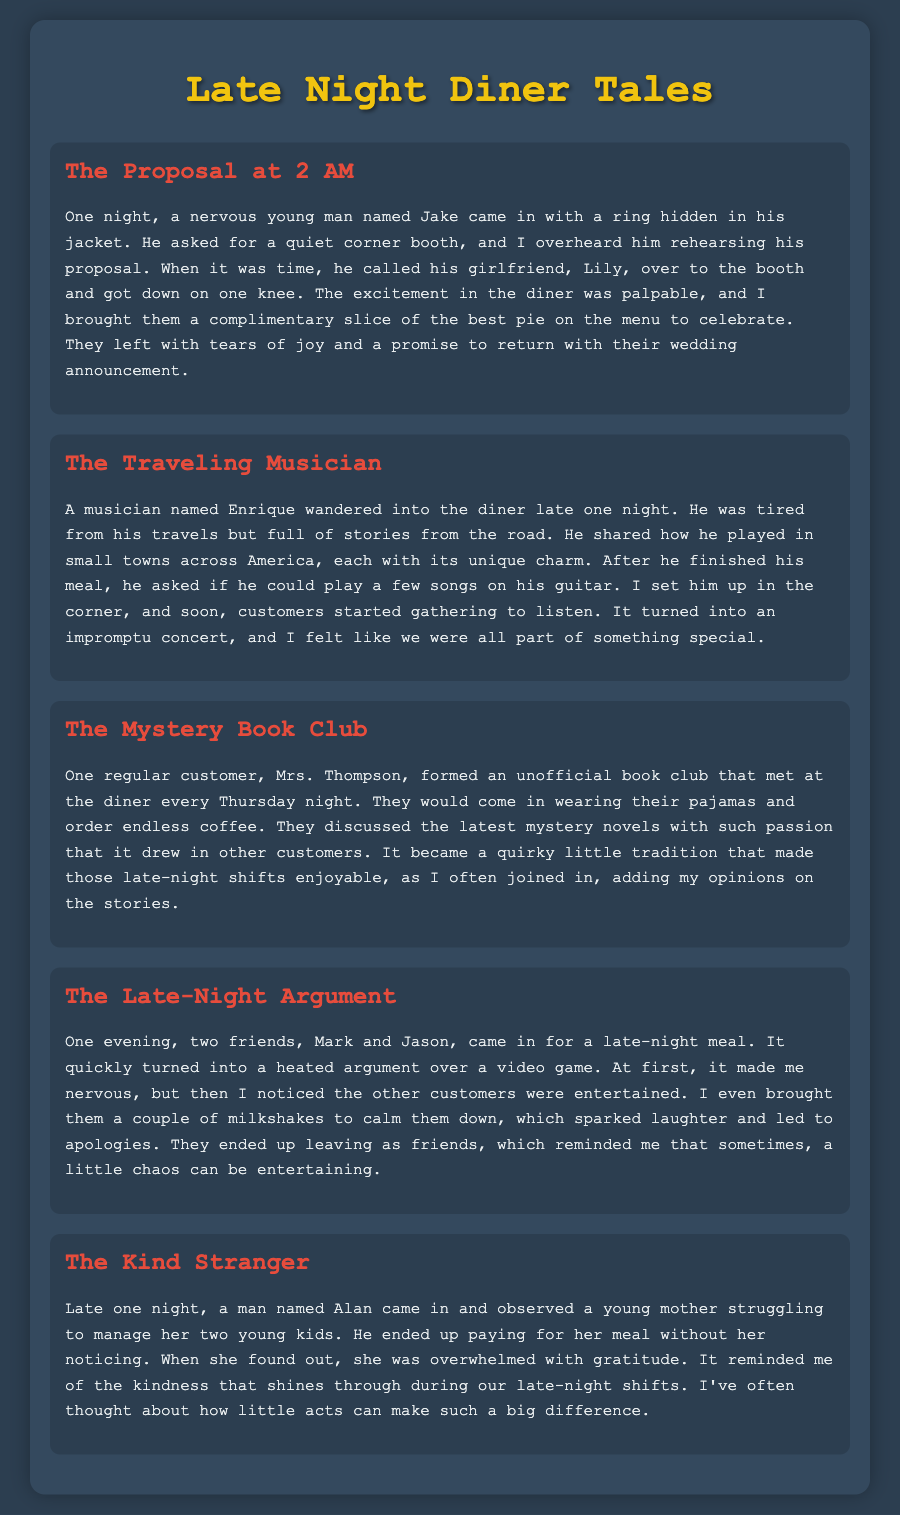what is the title of the document? The title of the document is displayed prominently at the top of the page.
Answer: Late Night Diner Tales who proposed at 2 AM? The story mentions a young man who proposed to his girlfriend late at night.
Answer: Jake what was brought to celebrate the proposal? The document notes a complimentary item given to the couple after the proposal.
Answer: a slice of pie who was the musician that played the guitar? The musician mentioned in the document shared stories and played music in the diner.
Answer: Enrique what does Mrs. Thompson's group discuss? The unofficial book club formed by a regular customer focuses on a specific genre of literature.
Answer: mystery novels how many friends were involved in the late-night argument? The story describes a conflict that arose between two friends during their visit.
Answer: two what did Alan do for the young mother? The story recounts a kind act performed by a patron for another diner.
Answer: paid for her meal what is the recurring theme in these stories? The document showcases various interactions that reflect certain human behaviors or acts.
Answer: kindness 